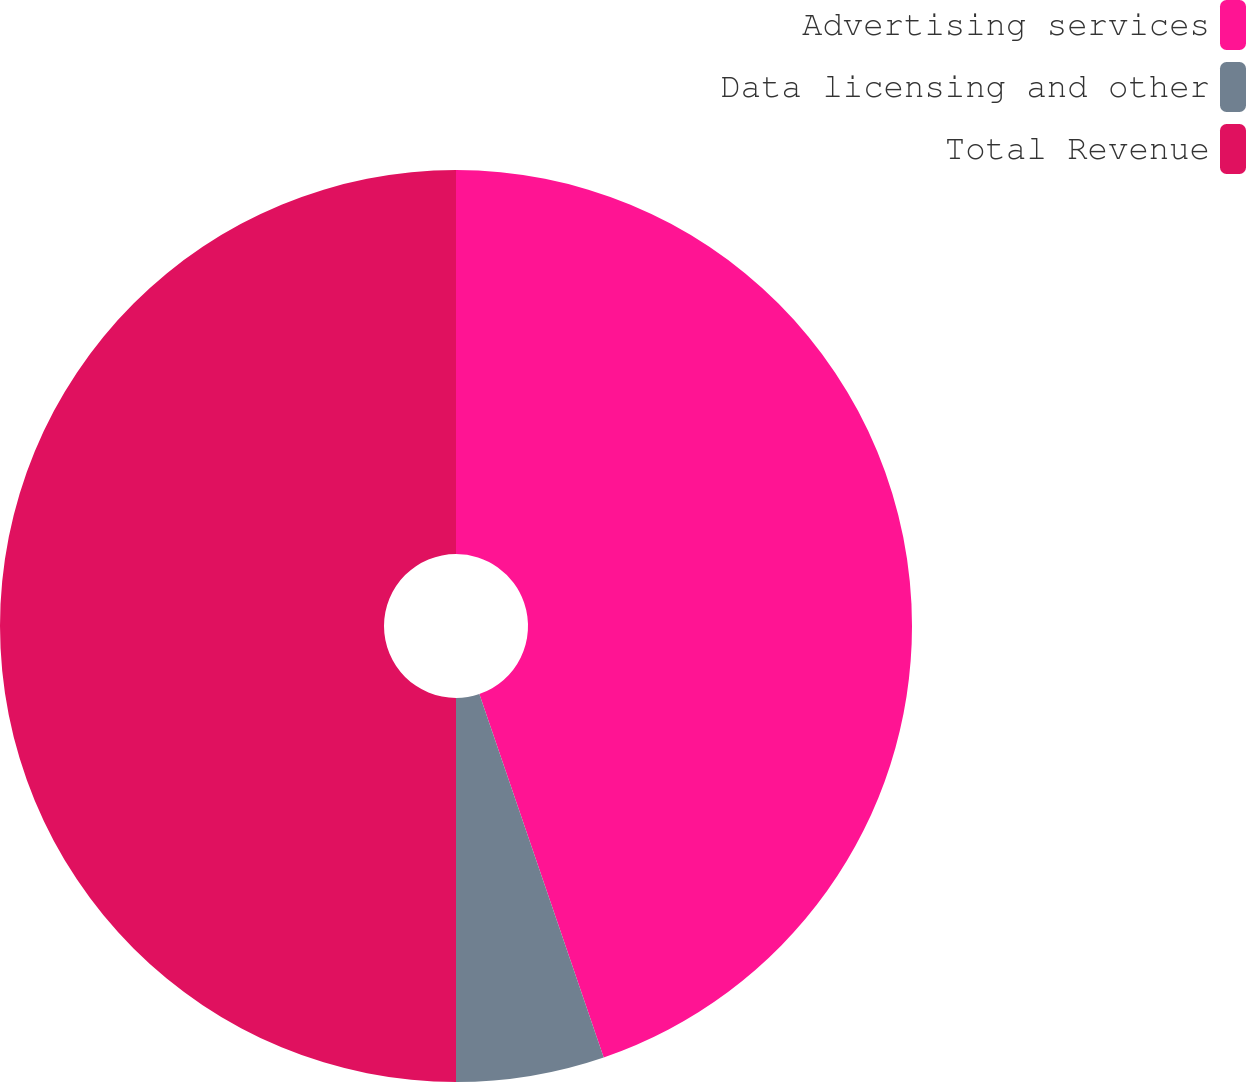Convert chart to OTSL. <chart><loc_0><loc_0><loc_500><loc_500><pie_chart><fcel>Advertising services<fcel>Data licensing and other<fcel>Total Revenue<nl><fcel>44.75%<fcel>5.25%<fcel>50.0%<nl></chart> 